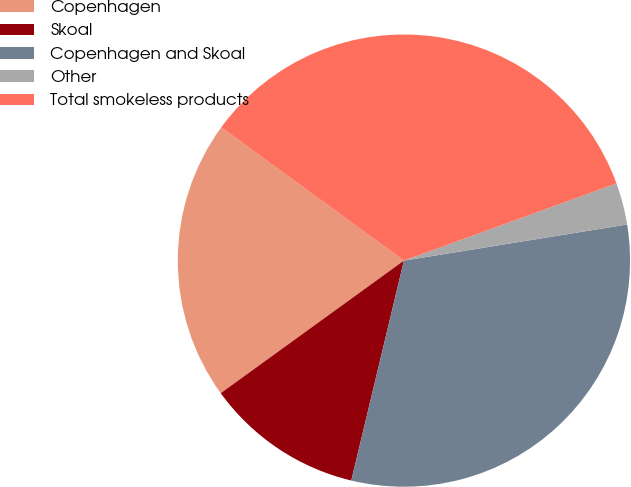Convert chart to OTSL. <chart><loc_0><loc_0><loc_500><loc_500><pie_chart><fcel>Copenhagen<fcel>Skoal<fcel>Copenhagen and Skoal<fcel>Other<fcel>Total smokeless products<nl><fcel>20.0%<fcel>11.29%<fcel>31.29%<fcel>2.99%<fcel>34.42%<nl></chart> 